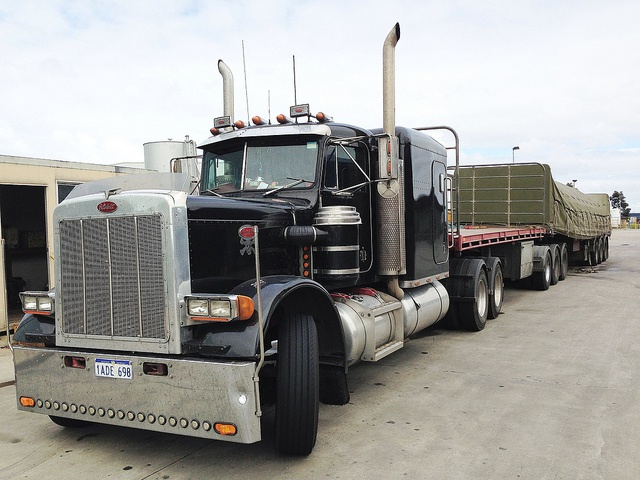Describe the objects in this image and their specific colors. I can see a truck in white, black, gray, darkgray, and lightgray tones in this image. 